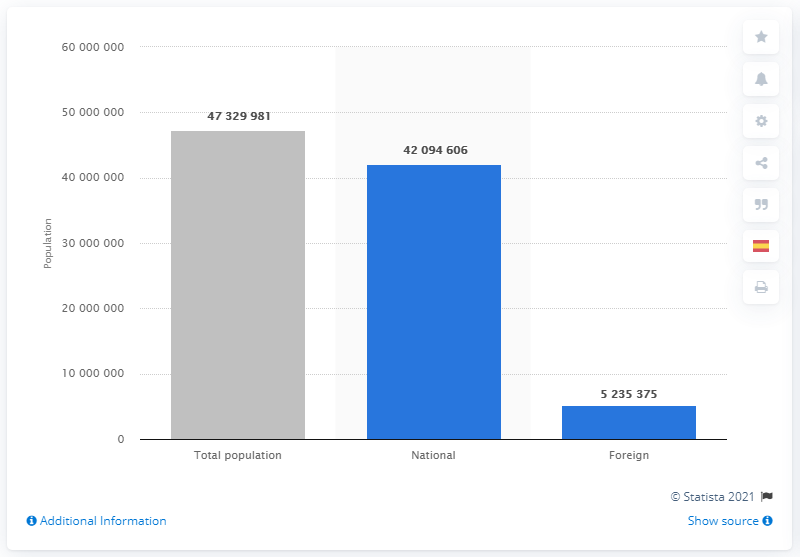Highlight a few significant elements in this photo. In January of 2020, there were 47,329,981 residents of Spain who were foreign residents. As of January 2020, it is estimated that approximately 47.3 million residents of Spain were foreign residents. In 2020, there were 420,946 Spanish-born residents living in Spain. 